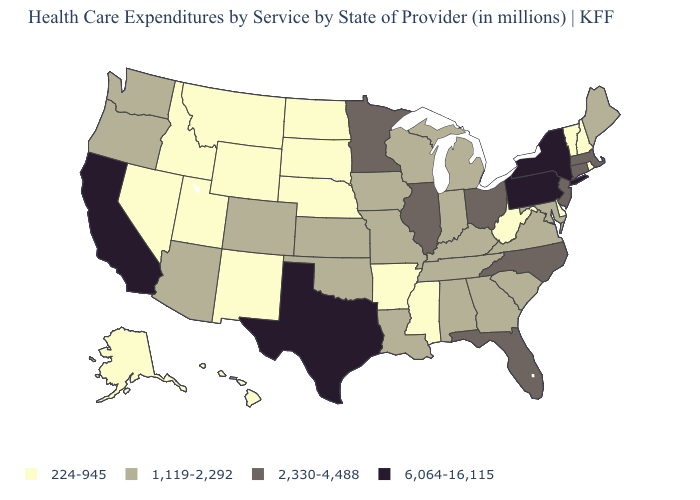Does Louisiana have a higher value than Connecticut?
Be succinct. No. Name the states that have a value in the range 224-945?
Quick response, please. Alaska, Arkansas, Delaware, Hawaii, Idaho, Mississippi, Montana, Nebraska, Nevada, New Hampshire, New Mexico, North Dakota, Rhode Island, South Dakota, Utah, Vermont, West Virginia, Wyoming. How many symbols are there in the legend?
Keep it brief. 4. What is the value of Michigan?
Keep it brief. 1,119-2,292. Name the states that have a value in the range 1,119-2,292?
Concise answer only. Alabama, Arizona, Colorado, Georgia, Indiana, Iowa, Kansas, Kentucky, Louisiana, Maine, Maryland, Michigan, Missouri, Oklahoma, Oregon, South Carolina, Tennessee, Virginia, Washington, Wisconsin. What is the value of Mississippi?
Short answer required. 224-945. Does Colorado have a lower value than Pennsylvania?
Concise answer only. Yes. Name the states that have a value in the range 1,119-2,292?
Be succinct. Alabama, Arizona, Colorado, Georgia, Indiana, Iowa, Kansas, Kentucky, Louisiana, Maine, Maryland, Michigan, Missouri, Oklahoma, Oregon, South Carolina, Tennessee, Virginia, Washington, Wisconsin. Does Wyoming have a lower value than New Hampshire?
Answer briefly. No. How many symbols are there in the legend?
Give a very brief answer. 4. What is the value of Tennessee?
Concise answer only. 1,119-2,292. Does the map have missing data?
Short answer required. No. Does New York have the highest value in the USA?
Write a very short answer. Yes. Does the first symbol in the legend represent the smallest category?
Quick response, please. Yes. Name the states that have a value in the range 1,119-2,292?
Short answer required. Alabama, Arizona, Colorado, Georgia, Indiana, Iowa, Kansas, Kentucky, Louisiana, Maine, Maryland, Michigan, Missouri, Oklahoma, Oregon, South Carolina, Tennessee, Virginia, Washington, Wisconsin. 